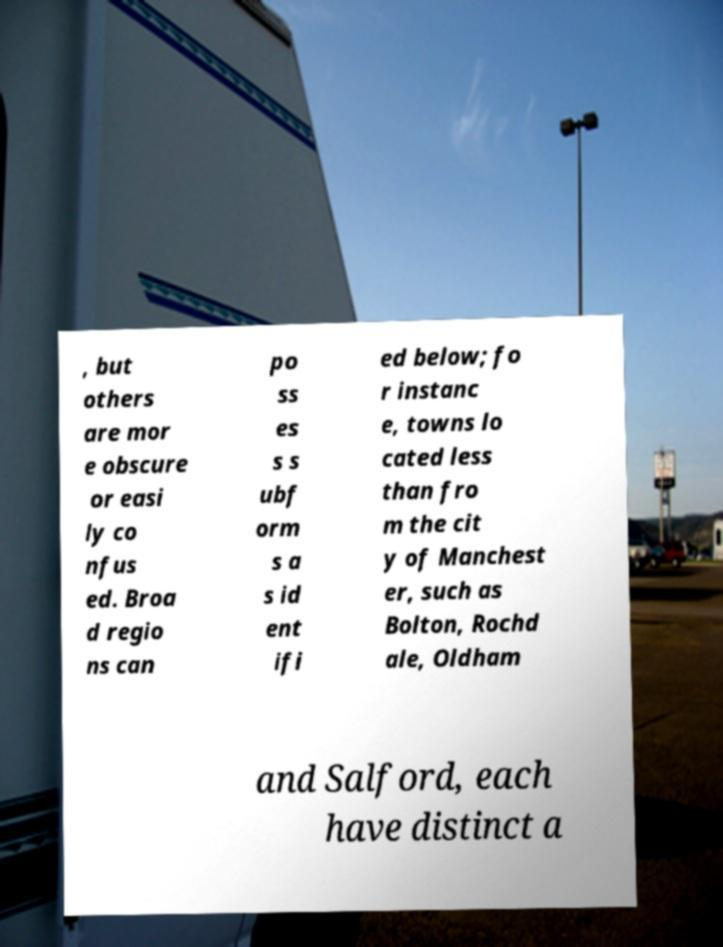Could you assist in decoding the text presented in this image and type it out clearly? , but others are mor e obscure or easi ly co nfus ed. Broa d regio ns can po ss es s s ubf orm s a s id ent ifi ed below; fo r instanc e, towns lo cated less than fro m the cit y of Manchest er, such as Bolton, Rochd ale, Oldham and Salford, each have distinct a 